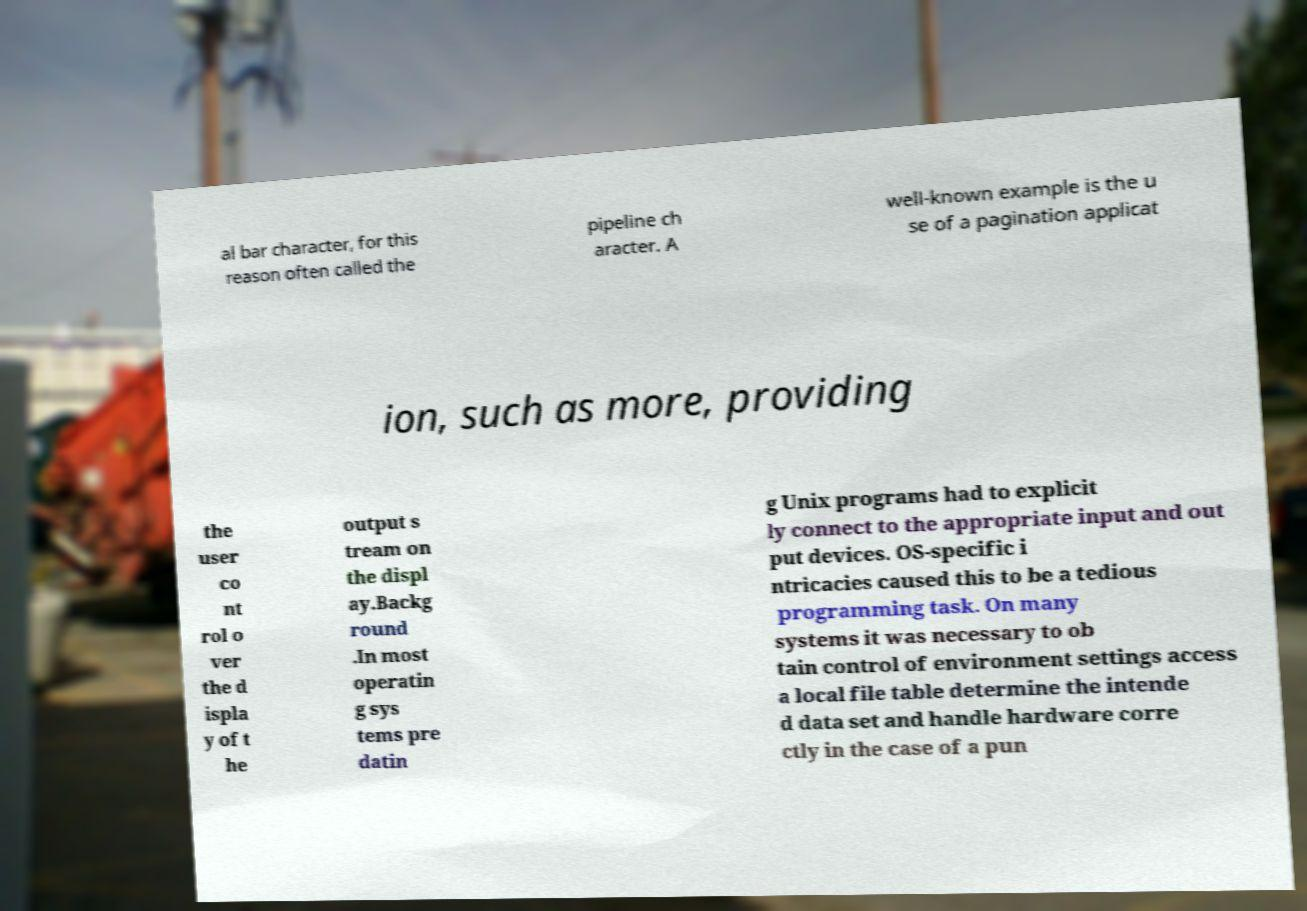Could you assist in decoding the text presented in this image and type it out clearly? al bar character, for this reason often called the pipeline ch aracter. A well-known example is the u se of a pagination applicat ion, such as more, providing the user co nt rol o ver the d ispla y of t he output s tream on the displ ay.Backg round .In most operatin g sys tems pre datin g Unix programs had to explicit ly connect to the appropriate input and out put devices. OS-specific i ntricacies caused this to be a tedious programming task. On many systems it was necessary to ob tain control of environment settings access a local file table determine the intende d data set and handle hardware corre ctly in the case of a pun 